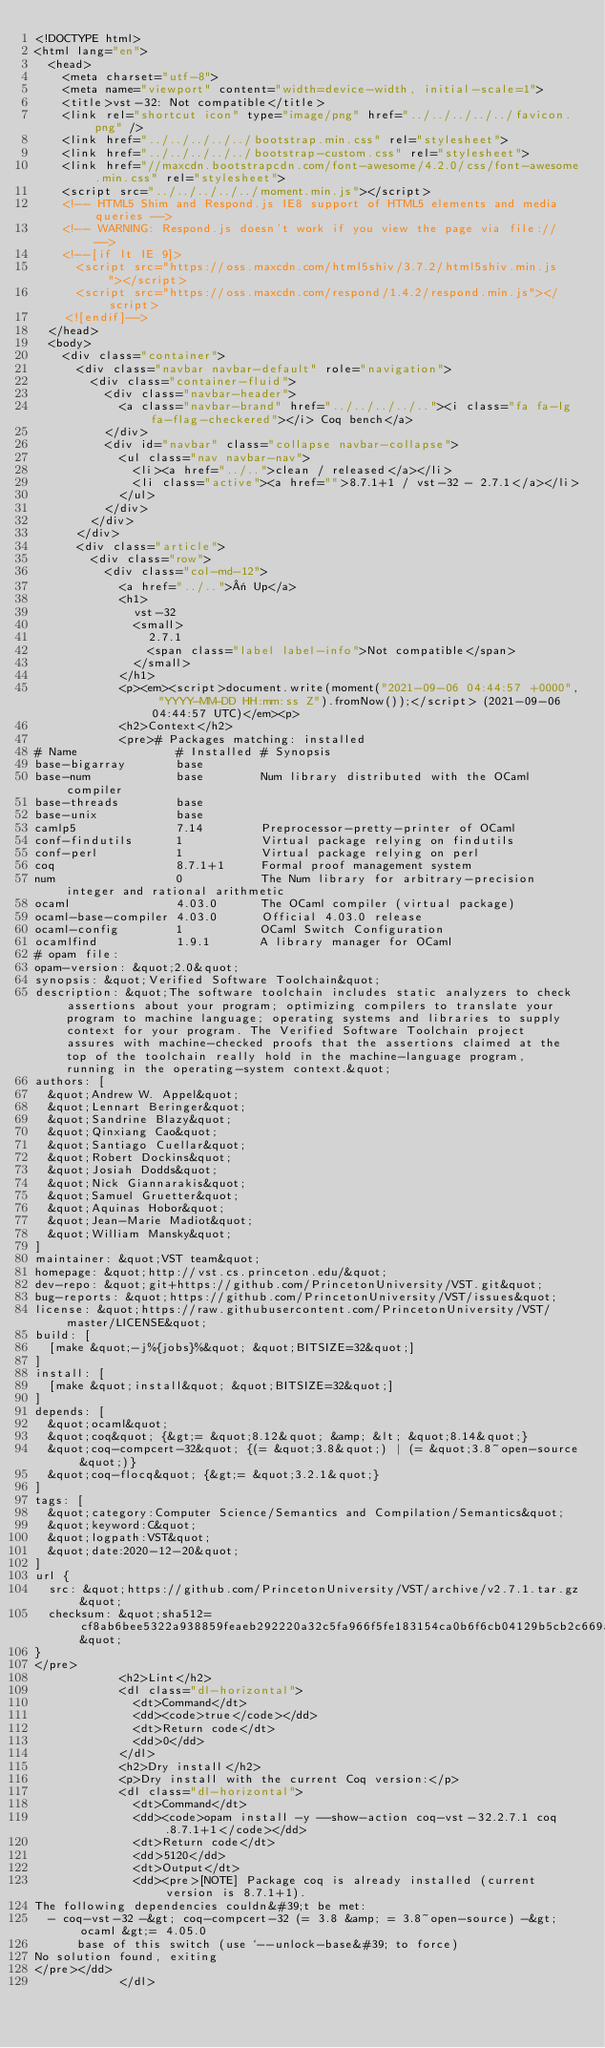Convert code to text. <code><loc_0><loc_0><loc_500><loc_500><_HTML_><!DOCTYPE html>
<html lang="en">
  <head>
    <meta charset="utf-8">
    <meta name="viewport" content="width=device-width, initial-scale=1">
    <title>vst-32: Not compatible</title>
    <link rel="shortcut icon" type="image/png" href="../../../../../favicon.png" />
    <link href="../../../../../bootstrap.min.css" rel="stylesheet">
    <link href="../../../../../bootstrap-custom.css" rel="stylesheet">
    <link href="//maxcdn.bootstrapcdn.com/font-awesome/4.2.0/css/font-awesome.min.css" rel="stylesheet">
    <script src="../../../../../moment.min.js"></script>
    <!-- HTML5 Shim and Respond.js IE8 support of HTML5 elements and media queries -->
    <!-- WARNING: Respond.js doesn't work if you view the page via file:// -->
    <!--[if lt IE 9]>
      <script src="https://oss.maxcdn.com/html5shiv/3.7.2/html5shiv.min.js"></script>
      <script src="https://oss.maxcdn.com/respond/1.4.2/respond.min.js"></script>
    <![endif]-->
  </head>
  <body>
    <div class="container">
      <div class="navbar navbar-default" role="navigation">
        <div class="container-fluid">
          <div class="navbar-header">
            <a class="navbar-brand" href="../../../../.."><i class="fa fa-lg fa-flag-checkered"></i> Coq bench</a>
          </div>
          <div id="navbar" class="collapse navbar-collapse">
            <ul class="nav navbar-nav">
              <li><a href="../..">clean / released</a></li>
              <li class="active"><a href="">8.7.1+1 / vst-32 - 2.7.1</a></li>
            </ul>
          </div>
        </div>
      </div>
      <div class="article">
        <div class="row">
          <div class="col-md-12">
            <a href="../..">« Up</a>
            <h1>
              vst-32
              <small>
                2.7.1
                <span class="label label-info">Not compatible</span>
              </small>
            </h1>
            <p><em><script>document.write(moment("2021-09-06 04:44:57 +0000", "YYYY-MM-DD HH:mm:ss Z").fromNow());</script> (2021-09-06 04:44:57 UTC)</em><p>
            <h2>Context</h2>
            <pre># Packages matching: installed
# Name              # Installed # Synopsis
base-bigarray       base
base-num            base        Num library distributed with the OCaml compiler
base-threads        base
base-unix           base
camlp5              7.14        Preprocessor-pretty-printer of OCaml
conf-findutils      1           Virtual package relying on findutils
conf-perl           1           Virtual package relying on perl
coq                 8.7.1+1     Formal proof management system
num                 0           The Num library for arbitrary-precision integer and rational arithmetic
ocaml               4.03.0      The OCaml compiler (virtual package)
ocaml-base-compiler 4.03.0      Official 4.03.0 release
ocaml-config        1           OCaml Switch Configuration
ocamlfind           1.9.1       A library manager for OCaml
# opam file:
opam-version: &quot;2.0&quot;
synopsis: &quot;Verified Software Toolchain&quot;
description: &quot;The software toolchain includes static analyzers to check assertions about your program; optimizing compilers to translate your program to machine language; operating systems and libraries to supply context for your program. The Verified Software Toolchain project assures with machine-checked proofs that the assertions claimed at the top of the toolchain really hold in the machine-language program, running in the operating-system context.&quot;
authors: [
  &quot;Andrew W. Appel&quot;
  &quot;Lennart Beringer&quot;
  &quot;Sandrine Blazy&quot;
  &quot;Qinxiang Cao&quot;
  &quot;Santiago Cuellar&quot;
  &quot;Robert Dockins&quot;
  &quot;Josiah Dodds&quot;
  &quot;Nick Giannarakis&quot;
  &quot;Samuel Gruetter&quot;
  &quot;Aquinas Hobor&quot;
  &quot;Jean-Marie Madiot&quot;
  &quot;William Mansky&quot;
]
maintainer: &quot;VST team&quot;
homepage: &quot;http://vst.cs.princeton.edu/&quot;
dev-repo: &quot;git+https://github.com/PrincetonUniversity/VST.git&quot;
bug-reports: &quot;https://github.com/PrincetonUniversity/VST/issues&quot;
license: &quot;https://raw.githubusercontent.com/PrincetonUniversity/VST/master/LICENSE&quot;
build: [
  [make &quot;-j%{jobs}%&quot; &quot;BITSIZE=32&quot;]
]
install: [
  [make &quot;install&quot; &quot;BITSIZE=32&quot;]
]
depends: [
  &quot;ocaml&quot;
  &quot;coq&quot; {&gt;= &quot;8.12&quot; &amp; &lt; &quot;8.14&quot;}
  &quot;coq-compcert-32&quot; {(= &quot;3.8&quot;) | (= &quot;3.8~open-source&quot;)}
  &quot;coq-flocq&quot; {&gt;= &quot;3.2.1&quot;}
]
tags: [
  &quot;category:Computer Science/Semantics and Compilation/Semantics&quot;
  &quot;keyword:C&quot;
  &quot;logpath:VST&quot;
  &quot;date:2020-12-20&quot;
]
url {
  src: &quot;https://github.com/PrincetonUniversity/VST/archive/v2.7.1.tar.gz&quot;
  checksum: &quot;sha512=cf8ab6bee5322a938859feaeb292220a32c5fa966f5fe183154ca0b6f6cb04129b5cb2c669af0ff1d95f6e962119f9eb0670c1b5150a62205c003650c625e455&quot;
}
</pre>
            <h2>Lint</h2>
            <dl class="dl-horizontal">
              <dt>Command</dt>
              <dd><code>true</code></dd>
              <dt>Return code</dt>
              <dd>0</dd>
            </dl>
            <h2>Dry install</h2>
            <p>Dry install with the current Coq version:</p>
            <dl class="dl-horizontal">
              <dt>Command</dt>
              <dd><code>opam install -y --show-action coq-vst-32.2.7.1 coq.8.7.1+1</code></dd>
              <dt>Return code</dt>
              <dd>5120</dd>
              <dt>Output</dt>
              <dd><pre>[NOTE] Package coq is already installed (current version is 8.7.1+1).
The following dependencies couldn&#39;t be met:
  - coq-vst-32 -&gt; coq-compcert-32 (= 3.8 &amp; = 3.8~open-source) -&gt; ocaml &gt;= 4.05.0
      base of this switch (use `--unlock-base&#39; to force)
No solution found, exiting
</pre></dd>
            </dl></code> 